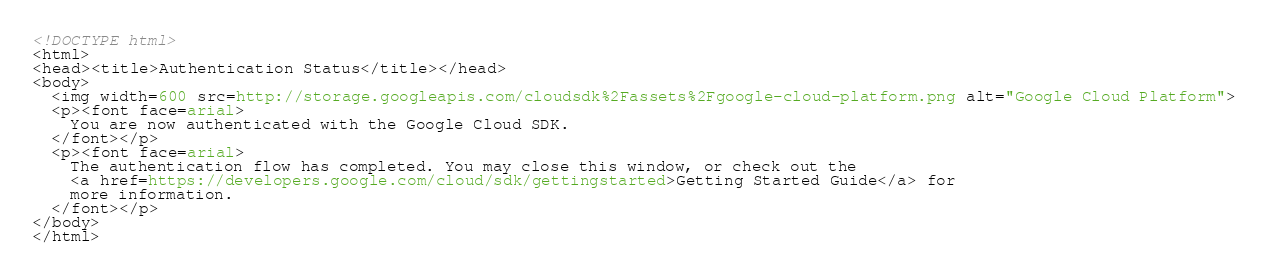<code> <loc_0><loc_0><loc_500><loc_500><_HTML_><!DOCTYPE html>
<html>
<head><title>Authentication Status</title></head>
<body>
  <img width=600 src=http://storage.googleapis.com/cloudsdk%2Fassets%2Fgoogle-cloud-platform.png alt="Google Cloud Platform">
  <p><font face=arial>
    You are now authenticated with the Google Cloud SDK.
  </font></p>
  <p><font face=arial>
    The authentication flow has completed. You may close this window, or check out the
    <a href=https://developers.google.com/cloud/sdk/gettingstarted>Getting Started Guide</a> for
    more information.
  </font></p>
</body>
</html>
</code> 